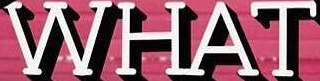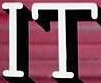What words are shown in these images in order, separated by a semicolon? WHAT; IT 